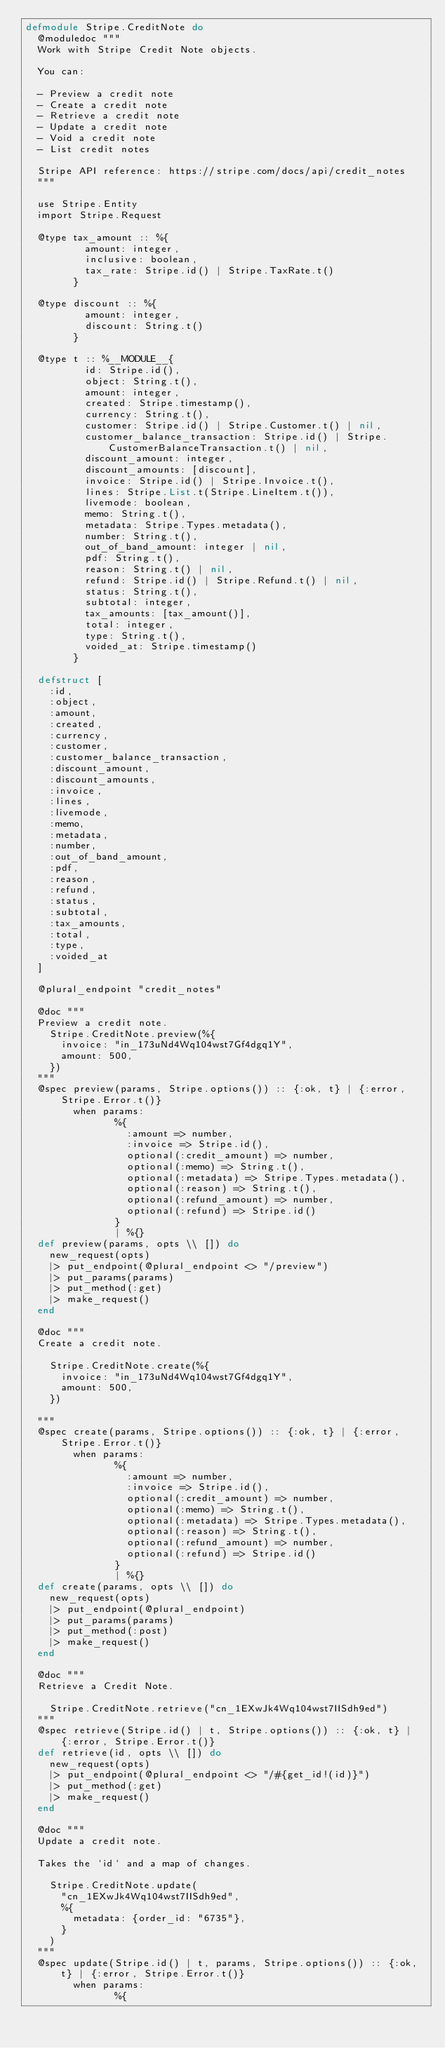Convert code to text. <code><loc_0><loc_0><loc_500><loc_500><_Elixir_>defmodule Stripe.CreditNote do
  @moduledoc """
  Work with Stripe Credit Note objects.

  You can:

  - Preview a credit note
  - Create a credit note
  - Retrieve a credit note
  - Update a credit note
  - Void a credit note
  - List credit notes

  Stripe API reference: https://stripe.com/docs/api/credit_notes
  """

  use Stripe.Entity
  import Stripe.Request

  @type tax_amount :: %{
          amount: integer,
          inclusive: boolean,
          tax_rate: Stripe.id() | Stripe.TaxRate.t()
        }

  @type discount :: %{
          amount: integer,
          discount: String.t()
        }

  @type t :: %__MODULE__{
          id: Stripe.id(),
          object: String.t(),
          amount: integer,
          created: Stripe.timestamp(),
          currency: String.t(),
          customer: Stripe.id() | Stripe.Customer.t() | nil,
          customer_balance_transaction: Stripe.id() | Stripe.CustomerBalanceTransaction.t() | nil,
          discount_amount: integer,
          discount_amounts: [discount],
          invoice: Stripe.id() | Stripe.Invoice.t(),
          lines: Stripe.List.t(Stripe.LineItem.t()),
          livemode: boolean,
          memo: String.t(),
          metadata: Stripe.Types.metadata(),
          number: String.t(),
          out_of_band_amount: integer | nil,
          pdf: String.t(),
          reason: String.t() | nil,
          refund: Stripe.id() | Stripe.Refund.t() | nil,
          status: String.t(),
          subtotal: integer,
          tax_amounts: [tax_amount()],
          total: integer,
          type: String.t(),
          voided_at: Stripe.timestamp()
        }

  defstruct [
    :id,
    :object,
    :amount,
    :created,
    :currency,
    :customer,
    :customer_balance_transaction,
    :discount_amount,
    :discount_amounts,
    :invoice,
    :lines,
    :livemode,
    :memo,
    :metadata,
    :number,
    :out_of_band_amount,
    :pdf,
    :reason,
    :refund,
    :status,
    :subtotal,
    :tax_amounts,
    :total,
    :type,
    :voided_at
  ]

  @plural_endpoint "credit_notes"

  @doc """
  Preview a credit note.
    Stripe.CreditNote.preview(%{
      invoice: "in_173uNd4Wq104wst7Gf4dgq1Y",
      amount: 500,
    })
  """
  @spec preview(params, Stripe.options()) :: {:ok, t} | {:error, Stripe.Error.t()}
        when params:
               %{
                 :amount => number,
                 :invoice => Stripe.id(),
                 optional(:credit_amount) => number,
                 optional(:memo) => String.t(),
                 optional(:metadata) => Stripe.Types.metadata(),
                 optional(:reason) => String.t(),
                 optional(:refund_amount) => number,
                 optional(:refund) => Stripe.id()
               }
               | %{}
  def preview(params, opts \\ []) do
    new_request(opts)
    |> put_endpoint(@plural_endpoint <> "/preview")
    |> put_params(params)
    |> put_method(:get)
    |> make_request()
  end

  @doc """
  Create a credit note.

    Stripe.CreditNote.create(%{
      invoice: "in_173uNd4Wq104wst7Gf4dgq1Y",
      amount: 500,
    })

  """
  @spec create(params, Stripe.options()) :: {:ok, t} | {:error, Stripe.Error.t()}
        when params:
               %{
                 :amount => number,
                 :invoice => Stripe.id(),
                 optional(:credit_amount) => number,
                 optional(:memo) => String.t(),
                 optional(:metadata) => Stripe.Types.metadata(),
                 optional(:reason) => String.t(),
                 optional(:refund_amount) => number,
                 optional(:refund) => Stripe.id()
               }
               | %{}
  def create(params, opts \\ []) do
    new_request(opts)
    |> put_endpoint(@plural_endpoint)
    |> put_params(params)
    |> put_method(:post)
    |> make_request()
  end

  @doc """
  Retrieve a Credit Note.

    Stripe.CreditNote.retrieve("cn_1EXwJk4Wq104wst7IISdh9ed")
  """
  @spec retrieve(Stripe.id() | t, Stripe.options()) :: {:ok, t} | {:error, Stripe.Error.t()}
  def retrieve(id, opts \\ []) do
    new_request(opts)
    |> put_endpoint(@plural_endpoint <> "/#{get_id!(id)}")
    |> put_method(:get)
    |> make_request()
  end

  @doc """
  Update a credit note.

  Takes the `id` and a map of changes.

    Stripe.CreditNote.update(
      "cn_1EXwJk4Wq104wst7IISdh9ed",
      %{
        metadata: {order_id: "6735"},
      }
    )
  """
  @spec update(Stripe.id() | t, params, Stripe.options()) :: {:ok, t} | {:error, Stripe.Error.t()}
        when params:
               %{</code> 